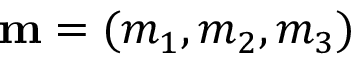Convert formula to latex. <formula><loc_0><loc_0><loc_500><loc_500>{ m } = ( m _ { 1 } , m _ { 2 } , m _ { 3 } )</formula> 